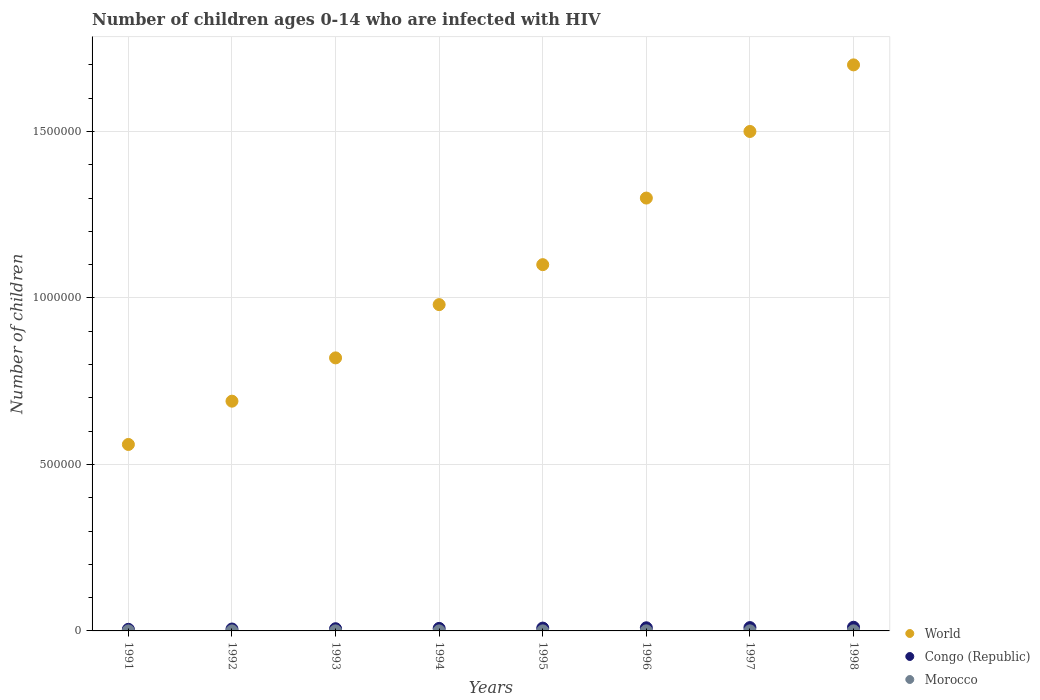What is the number of HIV infected children in Morocco in 1991?
Provide a short and direct response. 100. Across all years, what is the maximum number of HIV infected children in World?
Give a very brief answer. 1.70e+06. Across all years, what is the minimum number of HIV infected children in Morocco?
Your answer should be very brief. 100. In which year was the number of HIV infected children in World maximum?
Offer a very short reply. 1998. What is the total number of HIV infected children in Morocco in the graph?
Your response must be concise. 1100. What is the difference between the number of HIV infected children in Congo (Republic) in 1994 and that in 1995?
Offer a terse response. -900. What is the difference between the number of HIV infected children in World in 1998 and the number of HIV infected children in Morocco in 1997?
Provide a succinct answer. 1.70e+06. What is the average number of HIV infected children in Congo (Republic) per year?
Your answer should be compact. 7950. In the year 1992, what is the difference between the number of HIV infected children in Congo (Republic) and number of HIV infected children in World?
Provide a succinct answer. -6.84e+05. What is the difference between the highest and the lowest number of HIV infected children in Congo (Republic)?
Make the answer very short. 6200. In how many years, is the number of HIV infected children in World greater than the average number of HIV infected children in World taken over all years?
Your response must be concise. 4. Is the sum of the number of HIV infected children in Congo (Republic) in 1992 and 1993 greater than the maximum number of HIV infected children in World across all years?
Offer a very short reply. No. Is the number of HIV infected children in World strictly greater than the number of HIV infected children in Morocco over the years?
Ensure brevity in your answer.  Yes. How many dotlines are there?
Give a very brief answer. 3. What is the difference between two consecutive major ticks on the Y-axis?
Provide a short and direct response. 5.00e+05. How are the legend labels stacked?
Provide a succinct answer. Vertical. What is the title of the graph?
Provide a succinct answer. Number of children ages 0-14 who are infected with HIV. What is the label or title of the X-axis?
Your response must be concise. Years. What is the label or title of the Y-axis?
Your answer should be very brief. Number of children. What is the Number of children in World in 1991?
Offer a very short reply. 5.60e+05. What is the Number of children of Congo (Republic) in 1991?
Give a very brief answer. 4800. What is the Number of children of World in 1992?
Your response must be concise. 6.90e+05. What is the Number of children in Congo (Republic) in 1992?
Your response must be concise. 5700. What is the Number of children of World in 1993?
Your response must be concise. 8.20e+05. What is the Number of children of Congo (Republic) in 1993?
Offer a very short reply. 6600. What is the Number of children in World in 1994?
Provide a short and direct response. 9.80e+05. What is the Number of children of Congo (Republic) in 1994?
Your response must be concise. 7600. What is the Number of children in World in 1995?
Make the answer very short. 1.10e+06. What is the Number of children in Congo (Republic) in 1995?
Ensure brevity in your answer.  8500. What is the Number of children of World in 1996?
Make the answer very short. 1.30e+06. What is the Number of children of Congo (Republic) in 1996?
Your answer should be compact. 9400. What is the Number of children of World in 1997?
Offer a terse response. 1.50e+06. What is the Number of children in Congo (Republic) in 1997?
Offer a terse response. 10000. What is the Number of children in World in 1998?
Your answer should be compact. 1.70e+06. What is the Number of children of Congo (Republic) in 1998?
Make the answer very short. 1.10e+04. What is the Number of children in Morocco in 1998?
Ensure brevity in your answer.  200. Across all years, what is the maximum Number of children of World?
Your response must be concise. 1.70e+06. Across all years, what is the maximum Number of children in Congo (Republic)?
Your answer should be very brief. 1.10e+04. Across all years, what is the maximum Number of children of Morocco?
Your answer should be very brief. 200. Across all years, what is the minimum Number of children in World?
Make the answer very short. 5.60e+05. Across all years, what is the minimum Number of children in Congo (Republic)?
Ensure brevity in your answer.  4800. What is the total Number of children in World in the graph?
Ensure brevity in your answer.  8.65e+06. What is the total Number of children of Congo (Republic) in the graph?
Provide a short and direct response. 6.36e+04. What is the total Number of children in Morocco in the graph?
Your answer should be very brief. 1100. What is the difference between the Number of children of Congo (Republic) in 1991 and that in 1992?
Offer a terse response. -900. What is the difference between the Number of children in World in 1991 and that in 1993?
Your response must be concise. -2.60e+05. What is the difference between the Number of children in Congo (Republic) in 1991 and that in 1993?
Offer a very short reply. -1800. What is the difference between the Number of children in Morocco in 1991 and that in 1993?
Provide a short and direct response. 0. What is the difference between the Number of children of World in 1991 and that in 1994?
Keep it short and to the point. -4.20e+05. What is the difference between the Number of children in Congo (Republic) in 1991 and that in 1994?
Ensure brevity in your answer.  -2800. What is the difference between the Number of children in Morocco in 1991 and that in 1994?
Provide a short and direct response. 0. What is the difference between the Number of children of World in 1991 and that in 1995?
Your answer should be very brief. -5.40e+05. What is the difference between the Number of children in Congo (Republic) in 1991 and that in 1995?
Keep it short and to the point. -3700. What is the difference between the Number of children in Morocco in 1991 and that in 1995?
Your response must be concise. 0. What is the difference between the Number of children of World in 1991 and that in 1996?
Give a very brief answer. -7.40e+05. What is the difference between the Number of children in Congo (Republic) in 1991 and that in 1996?
Provide a succinct answer. -4600. What is the difference between the Number of children in Morocco in 1991 and that in 1996?
Ensure brevity in your answer.  -100. What is the difference between the Number of children of World in 1991 and that in 1997?
Your answer should be compact. -9.40e+05. What is the difference between the Number of children of Congo (Republic) in 1991 and that in 1997?
Give a very brief answer. -5200. What is the difference between the Number of children in Morocco in 1991 and that in 1997?
Give a very brief answer. -100. What is the difference between the Number of children of World in 1991 and that in 1998?
Your answer should be compact. -1.14e+06. What is the difference between the Number of children of Congo (Republic) in 1991 and that in 1998?
Offer a terse response. -6200. What is the difference between the Number of children in Morocco in 1991 and that in 1998?
Provide a succinct answer. -100. What is the difference between the Number of children of Congo (Republic) in 1992 and that in 1993?
Your answer should be very brief. -900. What is the difference between the Number of children of Congo (Republic) in 1992 and that in 1994?
Ensure brevity in your answer.  -1900. What is the difference between the Number of children of Morocco in 1992 and that in 1994?
Provide a short and direct response. 0. What is the difference between the Number of children in World in 1992 and that in 1995?
Your response must be concise. -4.10e+05. What is the difference between the Number of children in Congo (Republic) in 1992 and that in 1995?
Keep it short and to the point. -2800. What is the difference between the Number of children in Morocco in 1992 and that in 1995?
Your answer should be compact. 0. What is the difference between the Number of children in World in 1992 and that in 1996?
Provide a succinct answer. -6.10e+05. What is the difference between the Number of children of Congo (Republic) in 1992 and that in 1996?
Provide a succinct answer. -3700. What is the difference between the Number of children in Morocco in 1992 and that in 1996?
Give a very brief answer. -100. What is the difference between the Number of children in World in 1992 and that in 1997?
Your answer should be very brief. -8.10e+05. What is the difference between the Number of children in Congo (Republic) in 1992 and that in 1997?
Offer a very short reply. -4300. What is the difference between the Number of children in Morocco in 1992 and that in 1997?
Make the answer very short. -100. What is the difference between the Number of children in World in 1992 and that in 1998?
Offer a terse response. -1.01e+06. What is the difference between the Number of children in Congo (Republic) in 1992 and that in 1998?
Offer a terse response. -5300. What is the difference between the Number of children of Morocco in 1992 and that in 1998?
Your response must be concise. -100. What is the difference between the Number of children of Congo (Republic) in 1993 and that in 1994?
Your answer should be compact. -1000. What is the difference between the Number of children in World in 1993 and that in 1995?
Make the answer very short. -2.80e+05. What is the difference between the Number of children of Congo (Republic) in 1993 and that in 1995?
Offer a very short reply. -1900. What is the difference between the Number of children of Morocco in 1993 and that in 1995?
Your answer should be compact. 0. What is the difference between the Number of children in World in 1993 and that in 1996?
Provide a succinct answer. -4.80e+05. What is the difference between the Number of children of Congo (Republic) in 1993 and that in 1996?
Provide a succinct answer. -2800. What is the difference between the Number of children in Morocco in 1993 and that in 1996?
Give a very brief answer. -100. What is the difference between the Number of children of World in 1993 and that in 1997?
Keep it short and to the point. -6.80e+05. What is the difference between the Number of children of Congo (Republic) in 1993 and that in 1997?
Make the answer very short. -3400. What is the difference between the Number of children in Morocco in 1993 and that in 1997?
Offer a very short reply. -100. What is the difference between the Number of children of World in 1993 and that in 1998?
Make the answer very short. -8.80e+05. What is the difference between the Number of children of Congo (Republic) in 1993 and that in 1998?
Ensure brevity in your answer.  -4400. What is the difference between the Number of children in Morocco in 1993 and that in 1998?
Your answer should be very brief. -100. What is the difference between the Number of children in World in 1994 and that in 1995?
Ensure brevity in your answer.  -1.20e+05. What is the difference between the Number of children in Congo (Republic) in 1994 and that in 1995?
Ensure brevity in your answer.  -900. What is the difference between the Number of children in Morocco in 1994 and that in 1995?
Ensure brevity in your answer.  0. What is the difference between the Number of children in World in 1994 and that in 1996?
Provide a short and direct response. -3.20e+05. What is the difference between the Number of children in Congo (Republic) in 1994 and that in 1996?
Provide a short and direct response. -1800. What is the difference between the Number of children of Morocco in 1994 and that in 1996?
Give a very brief answer. -100. What is the difference between the Number of children in World in 1994 and that in 1997?
Offer a terse response. -5.20e+05. What is the difference between the Number of children of Congo (Republic) in 1994 and that in 1997?
Offer a very short reply. -2400. What is the difference between the Number of children in Morocco in 1994 and that in 1997?
Give a very brief answer. -100. What is the difference between the Number of children in World in 1994 and that in 1998?
Provide a short and direct response. -7.20e+05. What is the difference between the Number of children of Congo (Republic) in 1994 and that in 1998?
Keep it short and to the point. -3400. What is the difference between the Number of children of Morocco in 1994 and that in 1998?
Your answer should be very brief. -100. What is the difference between the Number of children in World in 1995 and that in 1996?
Offer a very short reply. -2.00e+05. What is the difference between the Number of children in Congo (Republic) in 1995 and that in 1996?
Offer a terse response. -900. What is the difference between the Number of children of Morocco in 1995 and that in 1996?
Offer a very short reply. -100. What is the difference between the Number of children in World in 1995 and that in 1997?
Provide a short and direct response. -4.00e+05. What is the difference between the Number of children of Congo (Republic) in 1995 and that in 1997?
Keep it short and to the point. -1500. What is the difference between the Number of children of Morocco in 1995 and that in 1997?
Offer a very short reply. -100. What is the difference between the Number of children of World in 1995 and that in 1998?
Provide a short and direct response. -6.00e+05. What is the difference between the Number of children in Congo (Republic) in 1995 and that in 1998?
Offer a very short reply. -2500. What is the difference between the Number of children in Morocco in 1995 and that in 1998?
Provide a succinct answer. -100. What is the difference between the Number of children of Congo (Republic) in 1996 and that in 1997?
Ensure brevity in your answer.  -600. What is the difference between the Number of children in Morocco in 1996 and that in 1997?
Provide a succinct answer. 0. What is the difference between the Number of children of World in 1996 and that in 1998?
Offer a terse response. -4.00e+05. What is the difference between the Number of children of Congo (Republic) in 1996 and that in 1998?
Your answer should be very brief. -1600. What is the difference between the Number of children of Morocco in 1996 and that in 1998?
Offer a terse response. 0. What is the difference between the Number of children in World in 1997 and that in 1998?
Give a very brief answer. -2.00e+05. What is the difference between the Number of children of Congo (Republic) in 1997 and that in 1998?
Your response must be concise. -1000. What is the difference between the Number of children in Morocco in 1997 and that in 1998?
Give a very brief answer. 0. What is the difference between the Number of children of World in 1991 and the Number of children of Congo (Republic) in 1992?
Provide a succinct answer. 5.54e+05. What is the difference between the Number of children of World in 1991 and the Number of children of Morocco in 1992?
Offer a very short reply. 5.60e+05. What is the difference between the Number of children in Congo (Republic) in 1991 and the Number of children in Morocco in 1992?
Your answer should be very brief. 4700. What is the difference between the Number of children of World in 1991 and the Number of children of Congo (Republic) in 1993?
Ensure brevity in your answer.  5.53e+05. What is the difference between the Number of children of World in 1991 and the Number of children of Morocco in 1993?
Give a very brief answer. 5.60e+05. What is the difference between the Number of children in Congo (Republic) in 1991 and the Number of children in Morocco in 1993?
Give a very brief answer. 4700. What is the difference between the Number of children in World in 1991 and the Number of children in Congo (Republic) in 1994?
Give a very brief answer. 5.52e+05. What is the difference between the Number of children in World in 1991 and the Number of children in Morocco in 1994?
Your answer should be compact. 5.60e+05. What is the difference between the Number of children in Congo (Republic) in 1991 and the Number of children in Morocco in 1994?
Keep it short and to the point. 4700. What is the difference between the Number of children in World in 1991 and the Number of children in Congo (Republic) in 1995?
Your answer should be very brief. 5.52e+05. What is the difference between the Number of children of World in 1991 and the Number of children of Morocco in 1995?
Your response must be concise. 5.60e+05. What is the difference between the Number of children of Congo (Republic) in 1991 and the Number of children of Morocco in 1995?
Ensure brevity in your answer.  4700. What is the difference between the Number of children of World in 1991 and the Number of children of Congo (Republic) in 1996?
Provide a succinct answer. 5.51e+05. What is the difference between the Number of children of World in 1991 and the Number of children of Morocco in 1996?
Keep it short and to the point. 5.60e+05. What is the difference between the Number of children in Congo (Republic) in 1991 and the Number of children in Morocco in 1996?
Make the answer very short. 4600. What is the difference between the Number of children in World in 1991 and the Number of children in Morocco in 1997?
Provide a short and direct response. 5.60e+05. What is the difference between the Number of children of Congo (Republic) in 1991 and the Number of children of Morocco in 1997?
Make the answer very short. 4600. What is the difference between the Number of children of World in 1991 and the Number of children of Congo (Republic) in 1998?
Offer a very short reply. 5.49e+05. What is the difference between the Number of children in World in 1991 and the Number of children in Morocco in 1998?
Provide a succinct answer. 5.60e+05. What is the difference between the Number of children in Congo (Republic) in 1991 and the Number of children in Morocco in 1998?
Make the answer very short. 4600. What is the difference between the Number of children in World in 1992 and the Number of children in Congo (Republic) in 1993?
Offer a terse response. 6.83e+05. What is the difference between the Number of children in World in 1992 and the Number of children in Morocco in 1993?
Provide a short and direct response. 6.90e+05. What is the difference between the Number of children of Congo (Republic) in 1992 and the Number of children of Morocco in 1993?
Give a very brief answer. 5600. What is the difference between the Number of children of World in 1992 and the Number of children of Congo (Republic) in 1994?
Offer a very short reply. 6.82e+05. What is the difference between the Number of children of World in 1992 and the Number of children of Morocco in 1994?
Keep it short and to the point. 6.90e+05. What is the difference between the Number of children in Congo (Republic) in 1992 and the Number of children in Morocco in 1994?
Provide a short and direct response. 5600. What is the difference between the Number of children of World in 1992 and the Number of children of Congo (Republic) in 1995?
Make the answer very short. 6.82e+05. What is the difference between the Number of children of World in 1992 and the Number of children of Morocco in 1995?
Ensure brevity in your answer.  6.90e+05. What is the difference between the Number of children of Congo (Republic) in 1992 and the Number of children of Morocco in 1995?
Provide a succinct answer. 5600. What is the difference between the Number of children in World in 1992 and the Number of children in Congo (Republic) in 1996?
Offer a very short reply. 6.81e+05. What is the difference between the Number of children of World in 1992 and the Number of children of Morocco in 1996?
Give a very brief answer. 6.90e+05. What is the difference between the Number of children of Congo (Republic) in 1992 and the Number of children of Morocco in 1996?
Your answer should be very brief. 5500. What is the difference between the Number of children of World in 1992 and the Number of children of Congo (Republic) in 1997?
Your response must be concise. 6.80e+05. What is the difference between the Number of children in World in 1992 and the Number of children in Morocco in 1997?
Ensure brevity in your answer.  6.90e+05. What is the difference between the Number of children of Congo (Republic) in 1992 and the Number of children of Morocco in 1997?
Offer a very short reply. 5500. What is the difference between the Number of children in World in 1992 and the Number of children in Congo (Republic) in 1998?
Your answer should be compact. 6.79e+05. What is the difference between the Number of children in World in 1992 and the Number of children in Morocco in 1998?
Provide a short and direct response. 6.90e+05. What is the difference between the Number of children of Congo (Republic) in 1992 and the Number of children of Morocco in 1998?
Keep it short and to the point. 5500. What is the difference between the Number of children in World in 1993 and the Number of children in Congo (Republic) in 1994?
Keep it short and to the point. 8.12e+05. What is the difference between the Number of children in World in 1993 and the Number of children in Morocco in 1994?
Your answer should be compact. 8.20e+05. What is the difference between the Number of children in Congo (Republic) in 1993 and the Number of children in Morocco in 1994?
Offer a terse response. 6500. What is the difference between the Number of children in World in 1993 and the Number of children in Congo (Republic) in 1995?
Ensure brevity in your answer.  8.12e+05. What is the difference between the Number of children in World in 1993 and the Number of children in Morocco in 1995?
Give a very brief answer. 8.20e+05. What is the difference between the Number of children of Congo (Republic) in 1993 and the Number of children of Morocco in 1995?
Your response must be concise. 6500. What is the difference between the Number of children of World in 1993 and the Number of children of Congo (Republic) in 1996?
Your response must be concise. 8.11e+05. What is the difference between the Number of children in World in 1993 and the Number of children in Morocco in 1996?
Offer a very short reply. 8.20e+05. What is the difference between the Number of children in Congo (Republic) in 1993 and the Number of children in Morocco in 1996?
Keep it short and to the point. 6400. What is the difference between the Number of children of World in 1993 and the Number of children of Congo (Republic) in 1997?
Ensure brevity in your answer.  8.10e+05. What is the difference between the Number of children in World in 1993 and the Number of children in Morocco in 1997?
Offer a terse response. 8.20e+05. What is the difference between the Number of children in Congo (Republic) in 1993 and the Number of children in Morocco in 1997?
Make the answer very short. 6400. What is the difference between the Number of children of World in 1993 and the Number of children of Congo (Republic) in 1998?
Offer a very short reply. 8.09e+05. What is the difference between the Number of children in World in 1993 and the Number of children in Morocco in 1998?
Give a very brief answer. 8.20e+05. What is the difference between the Number of children of Congo (Republic) in 1993 and the Number of children of Morocco in 1998?
Make the answer very short. 6400. What is the difference between the Number of children in World in 1994 and the Number of children in Congo (Republic) in 1995?
Make the answer very short. 9.72e+05. What is the difference between the Number of children of World in 1994 and the Number of children of Morocco in 1995?
Your answer should be very brief. 9.80e+05. What is the difference between the Number of children in Congo (Republic) in 1994 and the Number of children in Morocco in 1995?
Offer a very short reply. 7500. What is the difference between the Number of children in World in 1994 and the Number of children in Congo (Republic) in 1996?
Keep it short and to the point. 9.71e+05. What is the difference between the Number of children in World in 1994 and the Number of children in Morocco in 1996?
Provide a short and direct response. 9.80e+05. What is the difference between the Number of children in Congo (Republic) in 1994 and the Number of children in Morocco in 1996?
Your answer should be compact. 7400. What is the difference between the Number of children of World in 1994 and the Number of children of Congo (Republic) in 1997?
Offer a terse response. 9.70e+05. What is the difference between the Number of children of World in 1994 and the Number of children of Morocco in 1997?
Make the answer very short. 9.80e+05. What is the difference between the Number of children of Congo (Republic) in 1994 and the Number of children of Morocco in 1997?
Offer a terse response. 7400. What is the difference between the Number of children of World in 1994 and the Number of children of Congo (Republic) in 1998?
Your answer should be very brief. 9.69e+05. What is the difference between the Number of children of World in 1994 and the Number of children of Morocco in 1998?
Make the answer very short. 9.80e+05. What is the difference between the Number of children in Congo (Republic) in 1994 and the Number of children in Morocco in 1998?
Your response must be concise. 7400. What is the difference between the Number of children of World in 1995 and the Number of children of Congo (Republic) in 1996?
Make the answer very short. 1.09e+06. What is the difference between the Number of children of World in 1995 and the Number of children of Morocco in 1996?
Give a very brief answer. 1.10e+06. What is the difference between the Number of children of Congo (Republic) in 1995 and the Number of children of Morocco in 1996?
Your answer should be very brief. 8300. What is the difference between the Number of children of World in 1995 and the Number of children of Congo (Republic) in 1997?
Provide a short and direct response. 1.09e+06. What is the difference between the Number of children in World in 1995 and the Number of children in Morocco in 1997?
Ensure brevity in your answer.  1.10e+06. What is the difference between the Number of children of Congo (Republic) in 1995 and the Number of children of Morocco in 1997?
Make the answer very short. 8300. What is the difference between the Number of children of World in 1995 and the Number of children of Congo (Republic) in 1998?
Make the answer very short. 1.09e+06. What is the difference between the Number of children in World in 1995 and the Number of children in Morocco in 1998?
Your answer should be very brief. 1.10e+06. What is the difference between the Number of children of Congo (Republic) in 1995 and the Number of children of Morocco in 1998?
Provide a succinct answer. 8300. What is the difference between the Number of children in World in 1996 and the Number of children in Congo (Republic) in 1997?
Offer a very short reply. 1.29e+06. What is the difference between the Number of children of World in 1996 and the Number of children of Morocco in 1997?
Keep it short and to the point. 1.30e+06. What is the difference between the Number of children in Congo (Republic) in 1996 and the Number of children in Morocco in 1997?
Your answer should be very brief. 9200. What is the difference between the Number of children of World in 1996 and the Number of children of Congo (Republic) in 1998?
Provide a short and direct response. 1.29e+06. What is the difference between the Number of children of World in 1996 and the Number of children of Morocco in 1998?
Keep it short and to the point. 1.30e+06. What is the difference between the Number of children of Congo (Republic) in 1996 and the Number of children of Morocco in 1998?
Keep it short and to the point. 9200. What is the difference between the Number of children of World in 1997 and the Number of children of Congo (Republic) in 1998?
Provide a short and direct response. 1.49e+06. What is the difference between the Number of children in World in 1997 and the Number of children in Morocco in 1998?
Give a very brief answer. 1.50e+06. What is the difference between the Number of children of Congo (Republic) in 1997 and the Number of children of Morocco in 1998?
Offer a terse response. 9800. What is the average Number of children in World per year?
Provide a succinct answer. 1.08e+06. What is the average Number of children in Congo (Republic) per year?
Your response must be concise. 7950. What is the average Number of children of Morocco per year?
Ensure brevity in your answer.  137.5. In the year 1991, what is the difference between the Number of children of World and Number of children of Congo (Republic)?
Offer a very short reply. 5.55e+05. In the year 1991, what is the difference between the Number of children of World and Number of children of Morocco?
Make the answer very short. 5.60e+05. In the year 1991, what is the difference between the Number of children in Congo (Republic) and Number of children in Morocco?
Ensure brevity in your answer.  4700. In the year 1992, what is the difference between the Number of children in World and Number of children in Congo (Republic)?
Offer a terse response. 6.84e+05. In the year 1992, what is the difference between the Number of children of World and Number of children of Morocco?
Your answer should be very brief. 6.90e+05. In the year 1992, what is the difference between the Number of children in Congo (Republic) and Number of children in Morocco?
Your answer should be very brief. 5600. In the year 1993, what is the difference between the Number of children of World and Number of children of Congo (Republic)?
Offer a very short reply. 8.13e+05. In the year 1993, what is the difference between the Number of children of World and Number of children of Morocco?
Keep it short and to the point. 8.20e+05. In the year 1993, what is the difference between the Number of children in Congo (Republic) and Number of children in Morocco?
Offer a terse response. 6500. In the year 1994, what is the difference between the Number of children in World and Number of children in Congo (Republic)?
Your answer should be compact. 9.72e+05. In the year 1994, what is the difference between the Number of children in World and Number of children in Morocco?
Keep it short and to the point. 9.80e+05. In the year 1994, what is the difference between the Number of children of Congo (Republic) and Number of children of Morocco?
Ensure brevity in your answer.  7500. In the year 1995, what is the difference between the Number of children in World and Number of children in Congo (Republic)?
Your response must be concise. 1.09e+06. In the year 1995, what is the difference between the Number of children in World and Number of children in Morocco?
Your response must be concise. 1.10e+06. In the year 1995, what is the difference between the Number of children of Congo (Republic) and Number of children of Morocco?
Give a very brief answer. 8400. In the year 1996, what is the difference between the Number of children in World and Number of children in Congo (Republic)?
Ensure brevity in your answer.  1.29e+06. In the year 1996, what is the difference between the Number of children of World and Number of children of Morocco?
Offer a very short reply. 1.30e+06. In the year 1996, what is the difference between the Number of children of Congo (Republic) and Number of children of Morocco?
Provide a succinct answer. 9200. In the year 1997, what is the difference between the Number of children in World and Number of children in Congo (Republic)?
Your answer should be compact. 1.49e+06. In the year 1997, what is the difference between the Number of children in World and Number of children in Morocco?
Offer a terse response. 1.50e+06. In the year 1997, what is the difference between the Number of children in Congo (Republic) and Number of children in Morocco?
Your answer should be very brief. 9800. In the year 1998, what is the difference between the Number of children of World and Number of children of Congo (Republic)?
Offer a terse response. 1.69e+06. In the year 1998, what is the difference between the Number of children of World and Number of children of Morocco?
Provide a succinct answer. 1.70e+06. In the year 1998, what is the difference between the Number of children in Congo (Republic) and Number of children in Morocco?
Your answer should be compact. 1.08e+04. What is the ratio of the Number of children in World in 1991 to that in 1992?
Offer a very short reply. 0.81. What is the ratio of the Number of children of Congo (Republic) in 1991 to that in 1992?
Provide a short and direct response. 0.84. What is the ratio of the Number of children of Morocco in 1991 to that in 1992?
Provide a succinct answer. 1. What is the ratio of the Number of children in World in 1991 to that in 1993?
Your response must be concise. 0.68. What is the ratio of the Number of children in Congo (Republic) in 1991 to that in 1993?
Your answer should be very brief. 0.73. What is the ratio of the Number of children in World in 1991 to that in 1994?
Ensure brevity in your answer.  0.57. What is the ratio of the Number of children of Congo (Republic) in 1991 to that in 1994?
Provide a short and direct response. 0.63. What is the ratio of the Number of children of World in 1991 to that in 1995?
Provide a succinct answer. 0.51. What is the ratio of the Number of children of Congo (Republic) in 1991 to that in 1995?
Make the answer very short. 0.56. What is the ratio of the Number of children of World in 1991 to that in 1996?
Offer a terse response. 0.43. What is the ratio of the Number of children of Congo (Republic) in 1991 to that in 1996?
Offer a very short reply. 0.51. What is the ratio of the Number of children in World in 1991 to that in 1997?
Keep it short and to the point. 0.37. What is the ratio of the Number of children of Congo (Republic) in 1991 to that in 1997?
Offer a very short reply. 0.48. What is the ratio of the Number of children in World in 1991 to that in 1998?
Your answer should be compact. 0.33. What is the ratio of the Number of children in Congo (Republic) in 1991 to that in 1998?
Provide a succinct answer. 0.44. What is the ratio of the Number of children in World in 1992 to that in 1993?
Ensure brevity in your answer.  0.84. What is the ratio of the Number of children of Congo (Republic) in 1992 to that in 1993?
Give a very brief answer. 0.86. What is the ratio of the Number of children in Morocco in 1992 to that in 1993?
Offer a very short reply. 1. What is the ratio of the Number of children of World in 1992 to that in 1994?
Make the answer very short. 0.7. What is the ratio of the Number of children in Morocco in 1992 to that in 1994?
Your response must be concise. 1. What is the ratio of the Number of children of World in 1992 to that in 1995?
Your answer should be very brief. 0.63. What is the ratio of the Number of children in Congo (Republic) in 1992 to that in 1995?
Your response must be concise. 0.67. What is the ratio of the Number of children in World in 1992 to that in 1996?
Provide a short and direct response. 0.53. What is the ratio of the Number of children in Congo (Republic) in 1992 to that in 1996?
Keep it short and to the point. 0.61. What is the ratio of the Number of children in World in 1992 to that in 1997?
Provide a succinct answer. 0.46. What is the ratio of the Number of children in Congo (Republic) in 1992 to that in 1997?
Give a very brief answer. 0.57. What is the ratio of the Number of children in Morocco in 1992 to that in 1997?
Offer a very short reply. 0.5. What is the ratio of the Number of children of World in 1992 to that in 1998?
Keep it short and to the point. 0.41. What is the ratio of the Number of children of Congo (Republic) in 1992 to that in 1998?
Your response must be concise. 0.52. What is the ratio of the Number of children of Morocco in 1992 to that in 1998?
Your answer should be compact. 0.5. What is the ratio of the Number of children in World in 1993 to that in 1994?
Your response must be concise. 0.84. What is the ratio of the Number of children in Congo (Republic) in 1993 to that in 1994?
Offer a terse response. 0.87. What is the ratio of the Number of children in World in 1993 to that in 1995?
Keep it short and to the point. 0.75. What is the ratio of the Number of children of Congo (Republic) in 1993 to that in 1995?
Offer a very short reply. 0.78. What is the ratio of the Number of children of Morocco in 1993 to that in 1995?
Offer a very short reply. 1. What is the ratio of the Number of children in World in 1993 to that in 1996?
Your answer should be compact. 0.63. What is the ratio of the Number of children in Congo (Republic) in 1993 to that in 1996?
Your answer should be very brief. 0.7. What is the ratio of the Number of children of Morocco in 1993 to that in 1996?
Ensure brevity in your answer.  0.5. What is the ratio of the Number of children of World in 1993 to that in 1997?
Your answer should be compact. 0.55. What is the ratio of the Number of children in Congo (Republic) in 1993 to that in 1997?
Your answer should be compact. 0.66. What is the ratio of the Number of children in World in 1993 to that in 1998?
Your answer should be compact. 0.48. What is the ratio of the Number of children in Congo (Republic) in 1993 to that in 1998?
Your response must be concise. 0.6. What is the ratio of the Number of children of Morocco in 1993 to that in 1998?
Your response must be concise. 0.5. What is the ratio of the Number of children in World in 1994 to that in 1995?
Offer a very short reply. 0.89. What is the ratio of the Number of children in Congo (Republic) in 1994 to that in 1995?
Make the answer very short. 0.89. What is the ratio of the Number of children in Morocco in 1994 to that in 1995?
Ensure brevity in your answer.  1. What is the ratio of the Number of children of World in 1994 to that in 1996?
Offer a terse response. 0.75. What is the ratio of the Number of children of Congo (Republic) in 1994 to that in 1996?
Ensure brevity in your answer.  0.81. What is the ratio of the Number of children of Morocco in 1994 to that in 1996?
Offer a terse response. 0.5. What is the ratio of the Number of children of World in 1994 to that in 1997?
Offer a very short reply. 0.65. What is the ratio of the Number of children in Congo (Republic) in 1994 to that in 1997?
Offer a very short reply. 0.76. What is the ratio of the Number of children in Morocco in 1994 to that in 1997?
Offer a very short reply. 0.5. What is the ratio of the Number of children in World in 1994 to that in 1998?
Provide a succinct answer. 0.58. What is the ratio of the Number of children of Congo (Republic) in 1994 to that in 1998?
Provide a short and direct response. 0.69. What is the ratio of the Number of children of World in 1995 to that in 1996?
Give a very brief answer. 0.85. What is the ratio of the Number of children in Congo (Republic) in 1995 to that in 1996?
Make the answer very short. 0.9. What is the ratio of the Number of children in Morocco in 1995 to that in 1996?
Make the answer very short. 0.5. What is the ratio of the Number of children in World in 1995 to that in 1997?
Keep it short and to the point. 0.73. What is the ratio of the Number of children of Morocco in 1995 to that in 1997?
Give a very brief answer. 0.5. What is the ratio of the Number of children in World in 1995 to that in 1998?
Your response must be concise. 0.65. What is the ratio of the Number of children in Congo (Republic) in 1995 to that in 1998?
Ensure brevity in your answer.  0.77. What is the ratio of the Number of children in World in 1996 to that in 1997?
Give a very brief answer. 0.87. What is the ratio of the Number of children of Morocco in 1996 to that in 1997?
Make the answer very short. 1. What is the ratio of the Number of children in World in 1996 to that in 1998?
Provide a short and direct response. 0.76. What is the ratio of the Number of children in Congo (Republic) in 1996 to that in 1998?
Ensure brevity in your answer.  0.85. What is the ratio of the Number of children of Morocco in 1996 to that in 1998?
Provide a succinct answer. 1. What is the ratio of the Number of children in World in 1997 to that in 1998?
Give a very brief answer. 0.88. What is the ratio of the Number of children of Morocco in 1997 to that in 1998?
Your response must be concise. 1. What is the difference between the highest and the second highest Number of children of Congo (Republic)?
Give a very brief answer. 1000. What is the difference between the highest and the second highest Number of children in Morocco?
Ensure brevity in your answer.  0. What is the difference between the highest and the lowest Number of children in World?
Give a very brief answer. 1.14e+06. What is the difference between the highest and the lowest Number of children in Congo (Republic)?
Keep it short and to the point. 6200. 